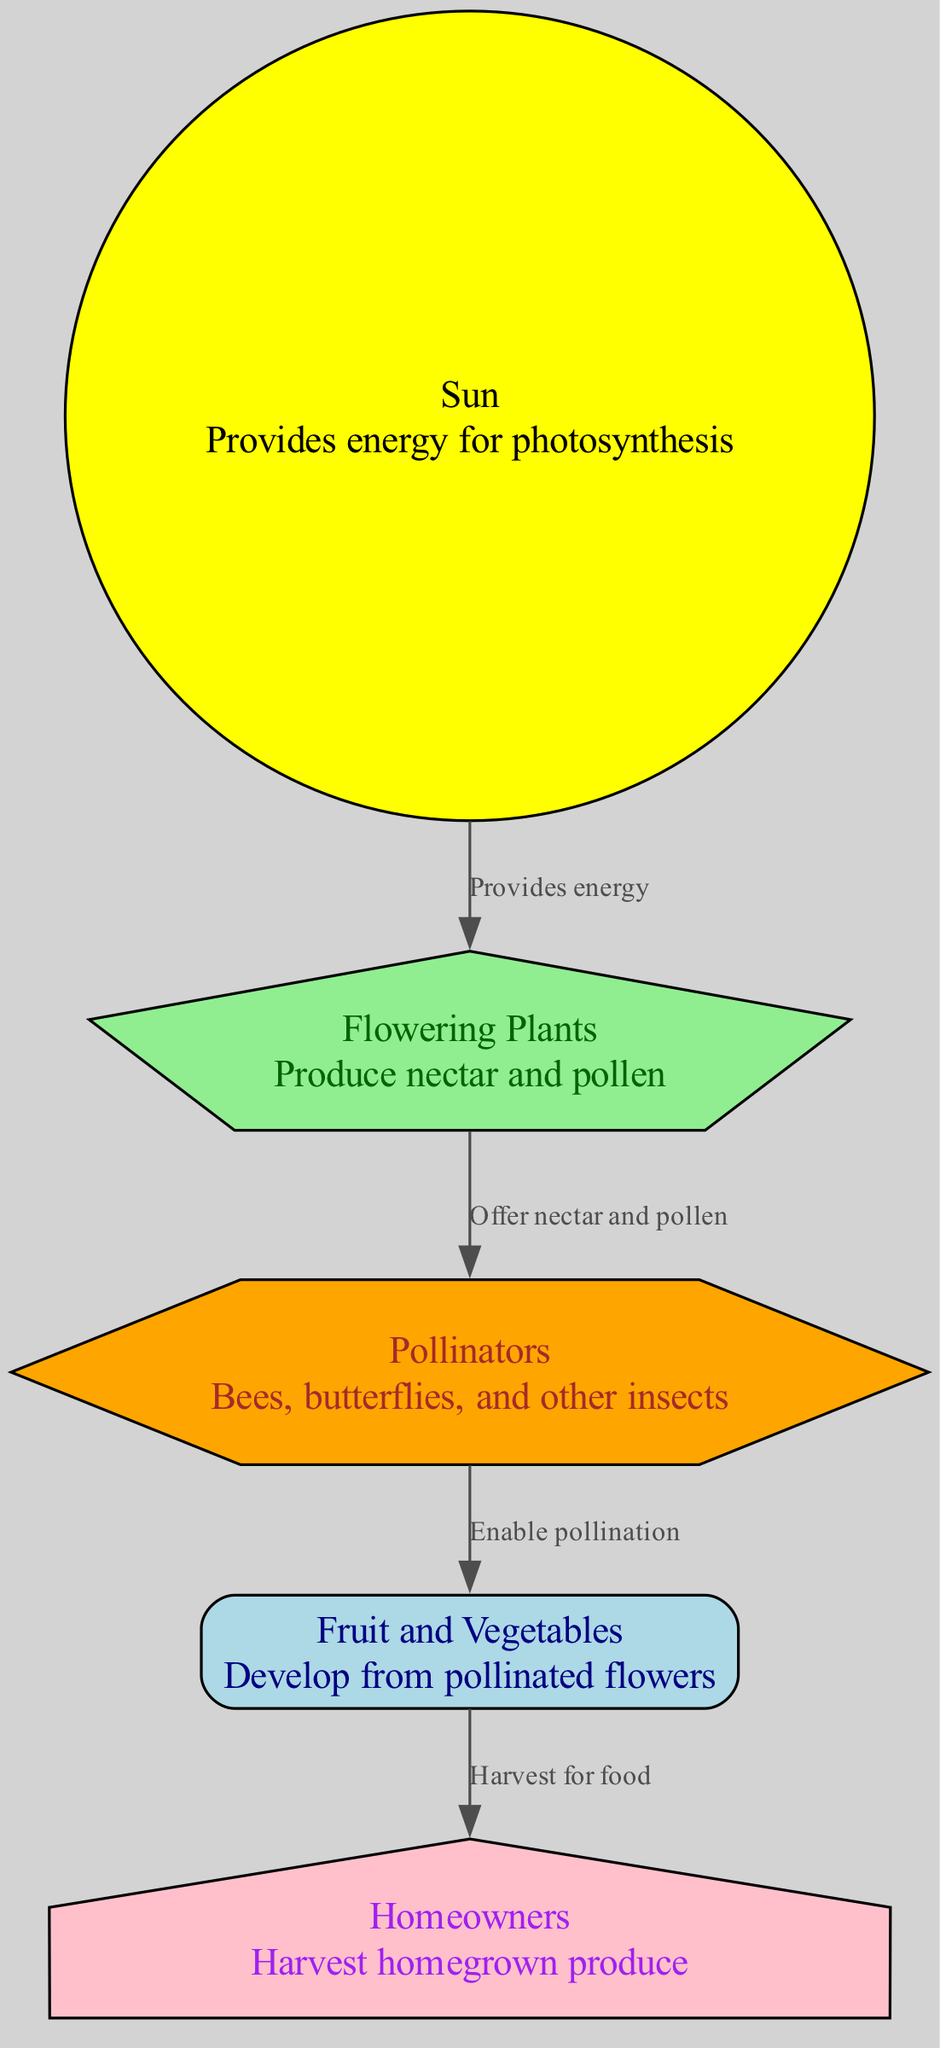What is the source of energy for flowering plants? According to the diagram, the sun is identified as the node that provides energy, as indicated in the description linked to it.
Answer: Sun How many edges are in the diagram? The diagram shows relationships between nodes. Counting the connections in the provided data, there are four edges between the nodes.
Answer: 4 Which node connects pollinators to fruit and vegetables? The diagram specifies that pollinators enable pollination to fruit and vegetables, clearly indicating the relationship in the edge description.
Answer: Fruit and Vegetables What do homeowners do with fruit and vegetables? The diagram conveys that homeowners harvest fruit and vegetables for food, as described in the edge leading from fruit and vegetables to homeowners.
Answer: Harvest for food What do flowering plants produce? According to the description associated with the flowering plants node, they produce nectar and pollen, which is the primary function outlined in the data.
Answer: Nectar and pollen Which node receives energy from the sun? The edge from the sun indicates that it connects to flowering plants, which are the nodes that directly receive energy.
Answer: Flowering Plants What role do pollinators play in the diagram? Pollinators offer nectar and pollen, as well as enabling pollination for fruit and vegetables, which is pivotal for the subsequent stages covering produce development.
Answer: Enable pollination How does the energy flow from the sun to homeowners? Energy from the sun first goes to flowering plants, which produce nectar and pollen consumed by pollinators, enabling the pollination of fruit and vegetables that are then harvested by homeowners. This chain illustrates the interconnectedness of each role.
Answer: Through four steps What is the shape of the homeowners node? The homeowners node is represented as a house shape, specifically described in the node styles within the diagram information.
Answer: House 